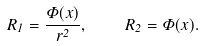Convert formula to latex. <formula><loc_0><loc_0><loc_500><loc_500>R _ { 1 } = \frac { \Phi ( x ) } { r ^ { 2 } } , \quad R _ { 2 } = \Phi ( x ) .</formula> 